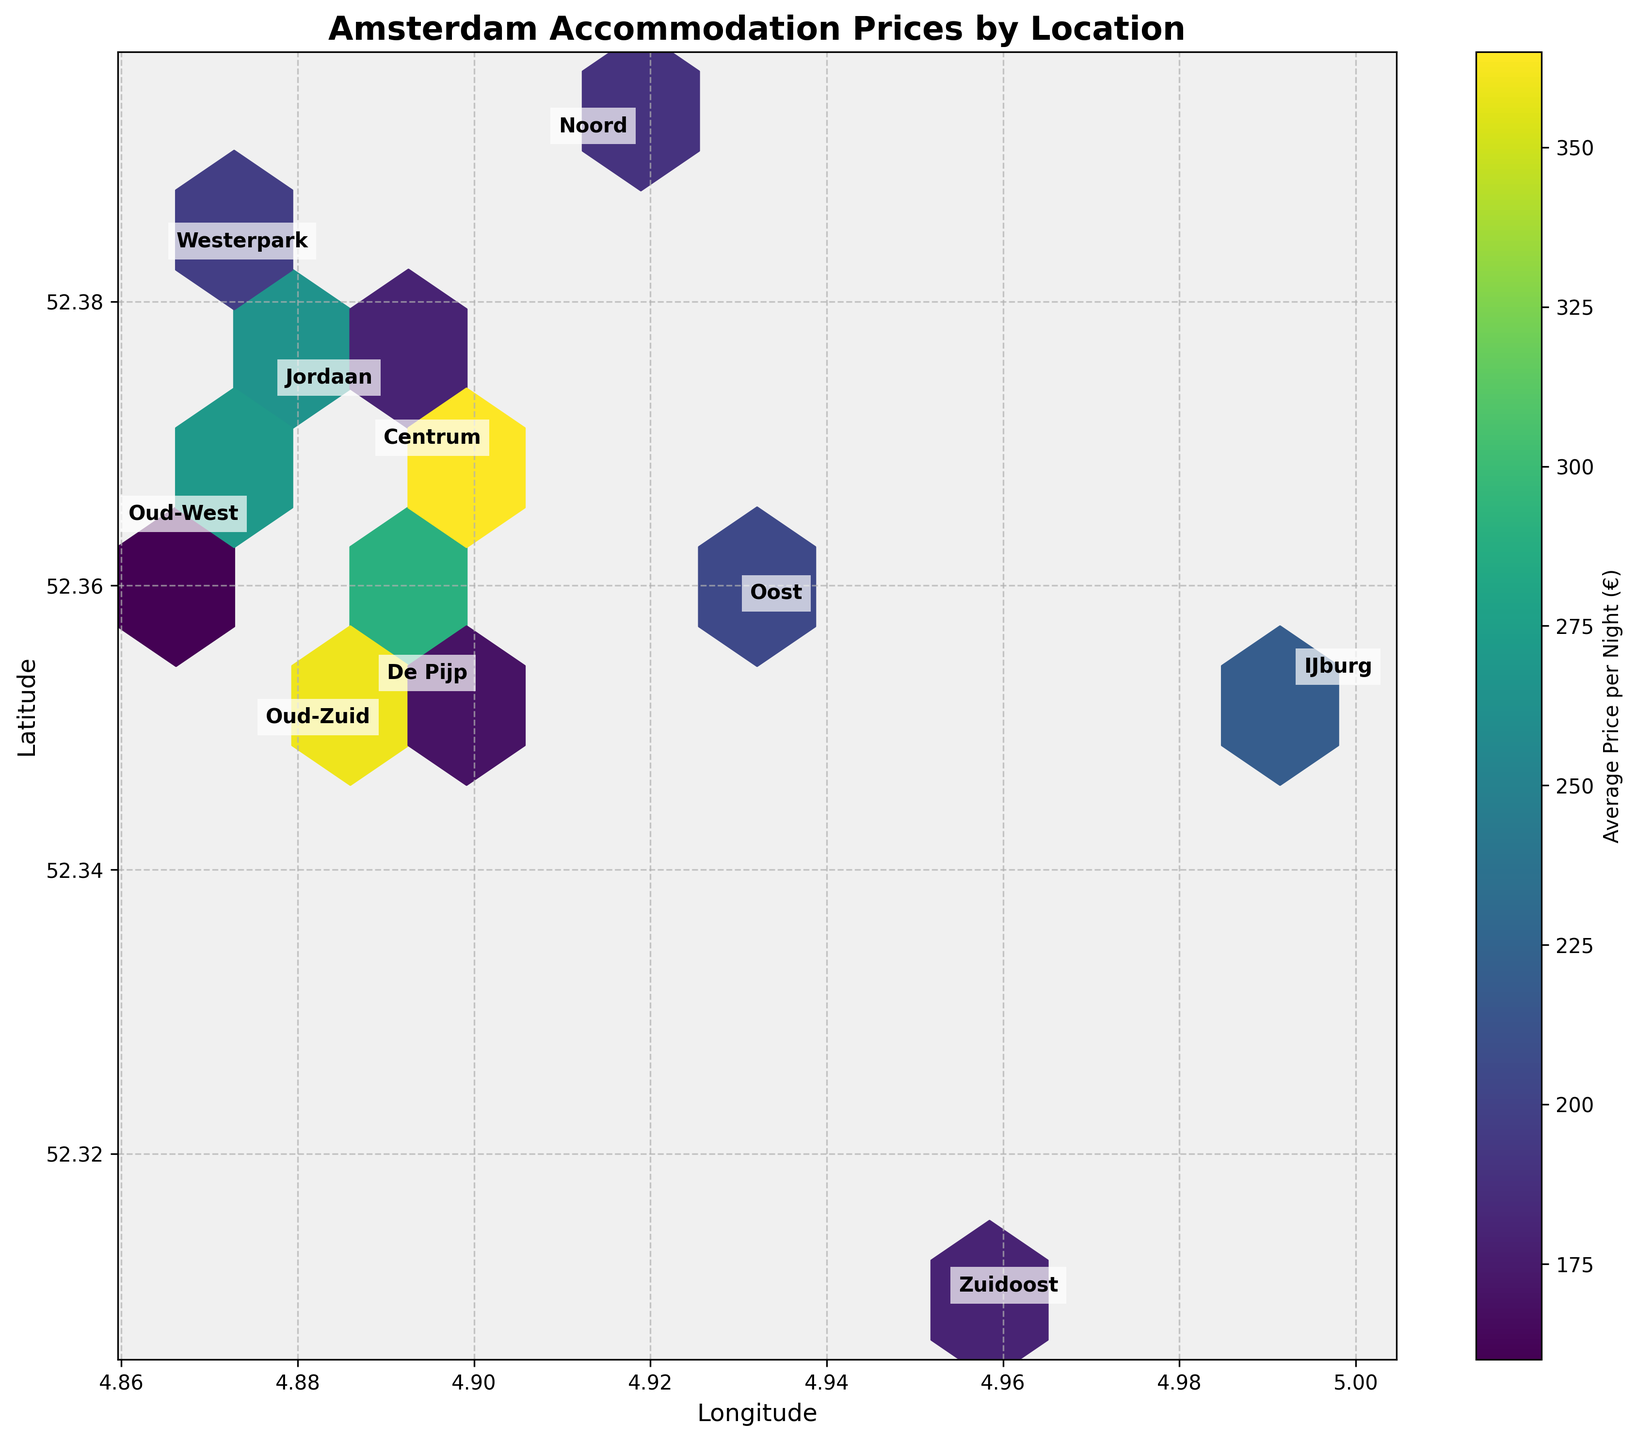What is the title of the plot? The title is written at the top of the plot and provides a summary of the chart content.
Answer: Amsterdam Accommodation Prices by Location Which neighborhood appears to have the highest average accommodation price? By looking at the color gradient in the hexbin plot, the darkest (highest average price) region appears around the centroid of the 'Centrum' neighborhood.
Answer: Centrum What do the colors in the hexbin plot represent? The colors represent the average price per night of accommodations in various locations, with darker colors indicating higher prices. This is explained in the color bar on the right side of the plot.
Answer: Average Price per Night (€) Is there a clear price difference between the center and the outskirts of the city? Comparing the color variation from the center to the outskirts, darker colors are concentrated around central neighborhoods and lighter colors in the outskirts, indicating higher prices in the center.
Answer: Yes Which neighborhood's centroid is closest to the latitude 52.3702 and longitude 4.8952? The centroid for the 'Centrum' neighborhood is marked near these coordinates, suggesting that it is closest to this location.
Answer: Centrum Which neighborhood has the lowest average accommodation price? To find the lowest average price, look for the lightest color in the plot. The Noord neighborhood appears to have the lightest hexagon color.
Answer: Noord What is the overall trend of accommodation prices as you move from the city center to the outer areas? The trend shows higher prices in the central areas (darker colors) and gradually decreasing prices as you move outward (lighter colors).
Answer: Prices decrease Comparing 'Centrum' and 'Oost', which has higher average accommodation prices? By comparing the color density, 'Centrum' has a darker shade indicating higher average prices than 'Oost'.
Answer: Centrum What is the significance of the annotated neighborhood names on the plot? The neighborhood names help identify the specific areas on the hexbin plot, providing contextual location information.
Answer: Identifies areas What additional information can be interpreted from the color bar aside from price? The color bar allows understanding of the gradient levels of average accommodation prices, making it easier to compare across locations.
Answer: Gradient levels 